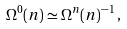Convert formula to latex. <formula><loc_0><loc_0><loc_500><loc_500>\Omega ^ { 0 } ( n ) \simeq \Omega ^ { n } ( n ) ^ { - 1 } \, ,</formula> 